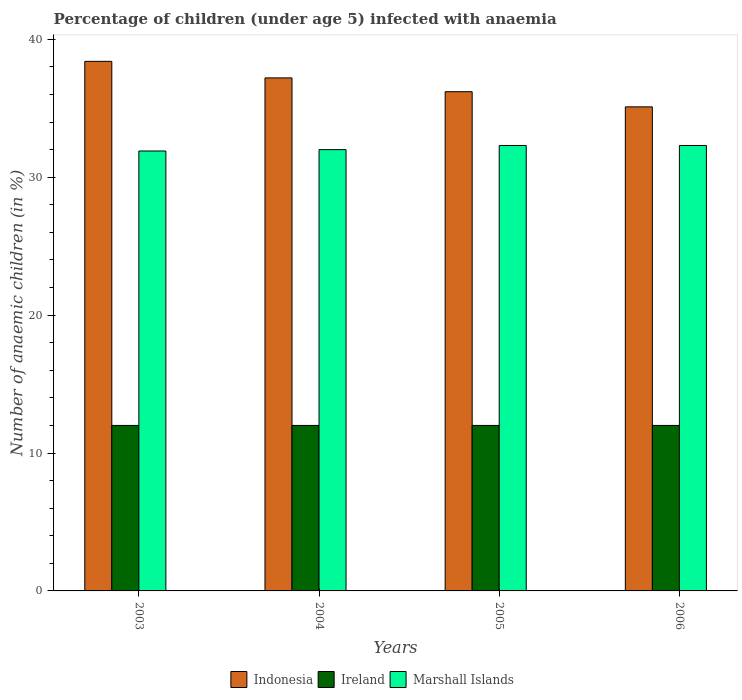How many different coloured bars are there?
Make the answer very short. 3. How many groups of bars are there?
Give a very brief answer. 4. What is the label of the 2nd group of bars from the left?
Provide a short and direct response. 2004. What is the percentage of children infected with anaemia in in Indonesia in 2006?
Keep it short and to the point. 35.1. Across all years, what is the maximum percentage of children infected with anaemia in in Marshall Islands?
Your answer should be very brief. 32.3. In which year was the percentage of children infected with anaemia in in Ireland minimum?
Make the answer very short. 2003. What is the difference between the percentage of children infected with anaemia in in Indonesia in 2003 and the percentage of children infected with anaemia in in Ireland in 2004?
Your answer should be compact. 26.4. What is the average percentage of children infected with anaemia in in Marshall Islands per year?
Offer a terse response. 32.12. In the year 2006, what is the difference between the percentage of children infected with anaemia in in Ireland and percentage of children infected with anaemia in in Marshall Islands?
Offer a terse response. -20.3. What is the ratio of the percentage of children infected with anaemia in in Marshall Islands in 2003 to that in 2006?
Provide a succinct answer. 0.99. What is the difference between the highest and the second highest percentage of children infected with anaemia in in Indonesia?
Provide a short and direct response. 1.2. What is the difference between the highest and the lowest percentage of children infected with anaemia in in Marshall Islands?
Provide a succinct answer. 0.4. What does the 1st bar from the left in 2006 represents?
Your response must be concise. Indonesia. What does the 1st bar from the right in 2006 represents?
Your answer should be compact. Marshall Islands. Are all the bars in the graph horizontal?
Offer a very short reply. No. Are the values on the major ticks of Y-axis written in scientific E-notation?
Your answer should be compact. No. Does the graph contain any zero values?
Your answer should be compact. No. Does the graph contain grids?
Your response must be concise. No. What is the title of the graph?
Keep it short and to the point. Percentage of children (under age 5) infected with anaemia. What is the label or title of the X-axis?
Your response must be concise. Years. What is the label or title of the Y-axis?
Your answer should be very brief. Number of anaemic children (in %). What is the Number of anaemic children (in %) in Indonesia in 2003?
Your answer should be compact. 38.4. What is the Number of anaemic children (in %) in Marshall Islands in 2003?
Provide a short and direct response. 31.9. What is the Number of anaemic children (in %) in Indonesia in 2004?
Give a very brief answer. 37.2. What is the Number of anaemic children (in %) in Ireland in 2004?
Provide a succinct answer. 12. What is the Number of anaemic children (in %) in Marshall Islands in 2004?
Your answer should be compact. 32. What is the Number of anaemic children (in %) of Indonesia in 2005?
Offer a very short reply. 36.2. What is the Number of anaemic children (in %) of Ireland in 2005?
Keep it short and to the point. 12. What is the Number of anaemic children (in %) in Marshall Islands in 2005?
Ensure brevity in your answer.  32.3. What is the Number of anaemic children (in %) in Indonesia in 2006?
Keep it short and to the point. 35.1. What is the Number of anaemic children (in %) in Marshall Islands in 2006?
Ensure brevity in your answer.  32.3. Across all years, what is the maximum Number of anaemic children (in %) of Indonesia?
Provide a short and direct response. 38.4. Across all years, what is the maximum Number of anaemic children (in %) in Marshall Islands?
Keep it short and to the point. 32.3. Across all years, what is the minimum Number of anaemic children (in %) of Indonesia?
Provide a succinct answer. 35.1. Across all years, what is the minimum Number of anaemic children (in %) in Ireland?
Give a very brief answer. 12. Across all years, what is the minimum Number of anaemic children (in %) in Marshall Islands?
Offer a terse response. 31.9. What is the total Number of anaemic children (in %) in Indonesia in the graph?
Give a very brief answer. 146.9. What is the total Number of anaemic children (in %) in Ireland in the graph?
Your answer should be compact. 48. What is the total Number of anaemic children (in %) of Marshall Islands in the graph?
Offer a very short reply. 128.5. What is the difference between the Number of anaemic children (in %) of Indonesia in 2003 and that in 2004?
Give a very brief answer. 1.2. What is the difference between the Number of anaemic children (in %) in Marshall Islands in 2003 and that in 2004?
Keep it short and to the point. -0.1. What is the difference between the Number of anaemic children (in %) in Indonesia in 2003 and that in 2005?
Offer a very short reply. 2.2. What is the difference between the Number of anaemic children (in %) of Marshall Islands in 2003 and that in 2005?
Your answer should be compact. -0.4. What is the difference between the Number of anaemic children (in %) of Indonesia in 2003 and that in 2006?
Provide a short and direct response. 3.3. What is the difference between the Number of anaemic children (in %) of Marshall Islands in 2003 and that in 2006?
Provide a short and direct response. -0.4. What is the difference between the Number of anaemic children (in %) in Indonesia in 2004 and that in 2006?
Provide a succinct answer. 2.1. What is the difference between the Number of anaemic children (in %) in Indonesia in 2005 and that in 2006?
Ensure brevity in your answer.  1.1. What is the difference between the Number of anaemic children (in %) of Ireland in 2005 and that in 2006?
Make the answer very short. 0. What is the difference between the Number of anaemic children (in %) of Marshall Islands in 2005 and that in 2006?
Provide a short and direct response. 0. What is the difference between the Number of anaemic children (in %) in Indonesia in 2003 and the Number of anaemic children (in %) in Ireland in 2004?
Your answer should be very brief. 26.4. What is the difference between the Number of anaemic children (in %) of Ireland in 2003 and the Number of anaemic children (in %) of Marshall Islands in 2004?
Give a very brief answer. -20. What is the difference between the Number of anaemic children (in %) of Indonesia in 2003 and the Number of anaemic children (in %) of Ireland in 2005?
Ensure brevity in your answer.  26.4. What is the difference between the Number of anaemic children (in %) of Indonesia in 2003 and the Number of anaemic children (in %) of Marshall Islands in 2005?
Keep it short and to the point. 6.1. What is the difference between the Number of anaemic children (in %) in Ireland in 2003 and the Number of anaemic children (in %) in Marshall Islands in 2005?
Your response must be concise. -20.3. What is the difference between the Number of anaemic children (in %) of Indonesia in 2003 and the Number of anaemic children (in %) of Ireland in 2006?
Provide a succinct answer. 26.4. What is the difference between the Number of anaemic children (in %) in Ireland in 2003 and the Number of anaemic children (in %) in Marshall Islands in 2006?
Offer a terse response. -20.3. What is the difference between the Number of anaemic children (in %) of Indonesia in 2004 and the Number of anaemic children (in %) of Ireland in 2005?
Offer a terse response. 25.2. What is the difference between the Number of anaemic children (in %) in Ireland in 2004 and the Number of anaemic children (in %) in Marshall Islands in 2005?
Give a very brief answer. -20.3. What is the difference between the Number of anaemic children (in %) of Indonesia in 2004 and the Number of anaemic children (in %) of Ireland in 2006?
Your answer should be very brief. 25.2. What is the difference between the Number of anaemic children (in %) of Indonesia in 2004 and the Number of anaemic children (in %) of Marshall Islands in 2006?
Your response must be concise. 4.9. What is the difference between the Number of anaemic children (in %) of Ireland in 2004 and the Number of anaemic children (in %) of Marshall Islands in 2006?
Offer a very short reply. -20.3. What is the difference between the Number of anaemic children (in %) of Indonesia in 2005 and the Number of anaemic children (in %) of Ireland in 2006?
Your answer should be very brief. 24.2. What is the difference between the Number of anaemic children (in %) of Ireland in 2005 and the Number of anaemic children (in %) of Marshall Islands in 2006?
Ensure brevity in your answer.  -20.3. What is the average Number of anaemic children (in %) of Indonesia per year?
Provide a short and direct response. 36.73. What is the average Number of anaemic children (in %) in Ireland per year?
Offer a terse response. 12. What is the average Number of anaemic children (in %) in Marshall Islands per year?
Provide a short and direct response. 32.12. In the year 2003, what is the difference between the Number of anaemic children (in %) of Indonesia and Number of anaemic children (in %) of Ireland?
Offer a very short reply. 26.4. In the year 2003, what is the difference between the Number of anaemic children (in %) of Indonesia and Number of anaemic children (in %) of Marshall Islands?
Your answer should be very brief. 6.5. In the year 2003, what is the difference between the Number of anaemic children (in %) of Ireland and Number of anaemic children (in %) of Marshall Islands?
Make the answer very short. -19.9. In the year 2004, what is the difference between the Number of anaemic children (in %) of Indonesia and Number of anaemic children (in %) of Ireland?
Your answer should be compact. 25.2. In the year 2004, what is the difference between the Number of anaemic children (in %) of Indonesia and Number of anaemic children (in %) of Marshall Islands?
Your response must be concise. 5.2. In the year 2004, what is the difference between the Number of anaemic children (in %) in Ireland and Number of anaemic children (in %) in Marshall Islands?
Provide a succinct answer. -20. In the year 2005, what is the difference between the Number of anaemic children (in %) in Indonesia and Number of anaemic children (in %) in Ireland?
Your answer should be very brief. 24.2. In the year 2005, what is the difference between the Number of anaemic children (in %) in Indonesia and Number of anaemic children (in %) in Marshall Islands?
Provide a succinct answer. 3.9. In the year 2005, what is the difference between the Number of anaemic children (in %) of Ireland and Number of anaemic children (in %) of Marshall Islands?
Offer a very short reply. -20.3. In the year 2006, what is the difference between the Number of anaemic children (in %) of Indonesia and Number of anaemic children (in %) of Ireland?
Provide a succinct answer. 23.1. In the year 2006, what is the difference between the Number of anaemic children (in %) of Indonesia and Number of anaemic children (in %) of Marshall Islands?
Give a very brief answer. 2.8. In the year 2006, what is the difference between the Number of anaemic children (in %) of Ireland and Number of anaemic children (in %) of Marshall Islands?
Keep it short and to the point. -20.3. What is the ratio of the Number of anaemic children (in %) in Indonesia in 2003 to that in 2004?
Provide a succinct answer. 1.03. What is the ratio of the Number of anaemic children (in %) of Marshall Islands in 2003 to that in 2004?
Give a very brief answer. 1. What is the ratio of the Number of anaemic children (in %) in Indonesia in 2003 to that in 2005?
Your answer should be very brief. 1.06. What is the ratio of the Number of anaemic children (in %) in Marshall Islands in 2003 to that in 2005?
Offer a terse response. 0.99. What is the ratio of the Number of anaemic children (in %) of Indonesia in 2003 to that in 2006?
Ensure brevity in your answer.  1.09. What is the ratio of the Number of anaemic children (in %) in Marshall Islands in 2003 to that in 2006?
Your response must be concise. 0.99. What is the ratio of the Number of anaemic children (in %) of Indonesia in 2004 to that in 2005?
Offer a terse response. 1.03. What is the ratio of the Number of anaemic children (in %) of Marshall Islands in 2004 to that in 2005?
Keep it short and to the point. 0.99. What is the ratio of the Number of anaemic children (in %) of Indonesia in 2004 to that in 2006?
Provide a succinct answer. 1.06. What is the ratio of the Number of anaemic children (in %) of Marshall Islands in 2004 to that in 2006?
Offer a very short reply. 0.99. What is the ratio of the Number of anaemic children (in %) in Indonesia in 2005 to that in 2006?
Give a very brief answer. 1.03. What is the difference between the highest and the second highest Number of anaemic children (in %) in Ireland?
Give a very brief answer. 0. What is the difference between the highest and the second highest Number of anaemic children (in %) in Marshall Islands?
Your response must be concise. 0. What is the difference between the highest and the lowest Number of anaemic children (in %) of Ireland?
Offer a very short reply. 0. What is the difference between the highest and the lowest Number of anaemic children (in %) of Marshall Islands?
Give a very brief answer. 0.4. 